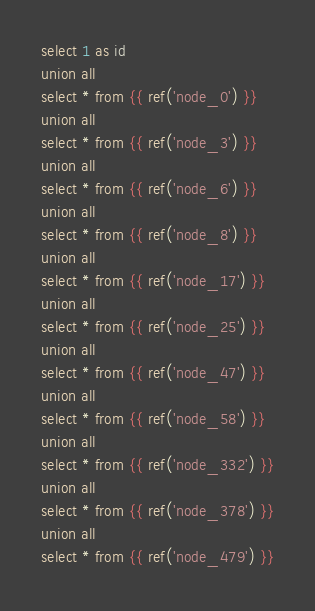Convert code to text. <code><loc_0><loc_0><loc_500><loc_500><_SQL_>select 1 as id
union all
select * from {{ ref('node_0') }}
union all
select * from {{ ref('node_3') }}
union all
select * from {{ ref('node_6') }}
union all
select * from {{ ref('node_8') }}
union all
select * from {{ ref('node_17') }}
union all
select * from {{ ref('node_25') }}
union all
select * from {{ ref('node_47') }}
union all
select * from {{ ref('node_58') }}
union all
select * from {{ ref('node_332') }}
union all
select * from {{ ref('node_378') }}
union all
select * from {{ ref('node_479') }}
</code> 